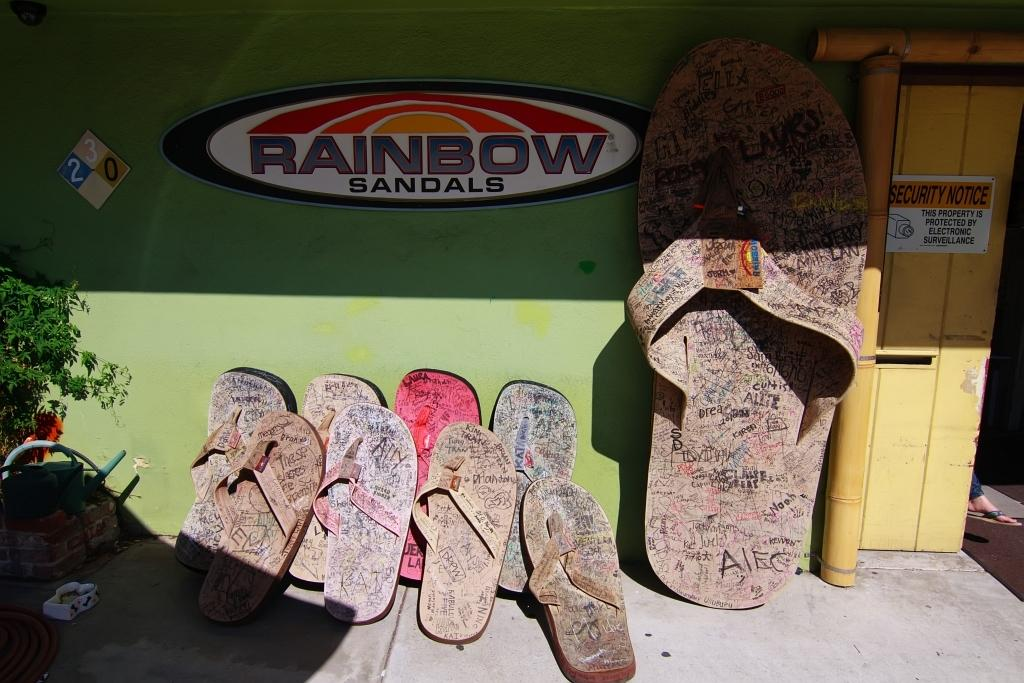What type of footwear is located near the wall in the image? There are slippers near the wall in the image. What can be found on the left side of the image? There are baskets and a plant on the left side of the image. What is the location of the door in the image? There is a door on the right side of the image. Can you describe what is behind the door in the image? A person's leg is visible behind the door in the image. What type of fork can be seen creating a rhythm in the image? There is no fork present in the image, nor is there any indication of rhythm or musical activity. 